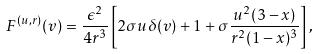<formula> <loc_0><loc_0><loc_500><loc_500>F ^ { ( u , r ) } ( v ) = \frac { \epsilon ^ { 2 } } { 4 r ^ { 3 } } \left [ 2 \sigma { u } \delta ( v ) + 1 + \sigma \frac { u ^ { 2 } ( 3 - x ) } { r ^ { 2 } ( 1 - x ) ^ { 3 } } \right ] ,</formula> 